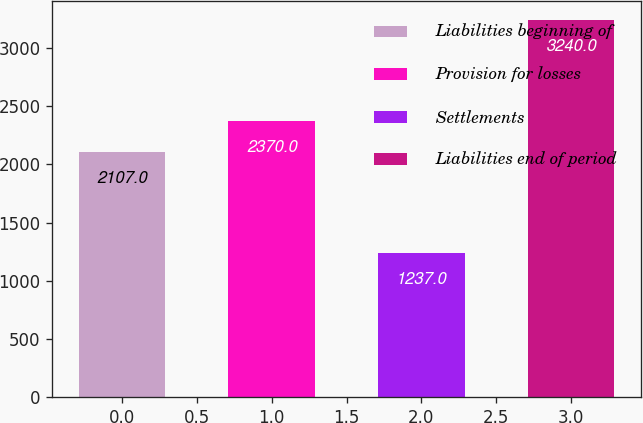<chart> <loc_0><loc_0><loc_500><loc_500><bar_chart><fcel>Liabilities beginning of<fcel>Provision for losses<fcel>Settlements<fcel>Liabilities end of period<nl><fcel>2107<fcel>2370<fcel>1237<fcel>3240<nl></chart> 